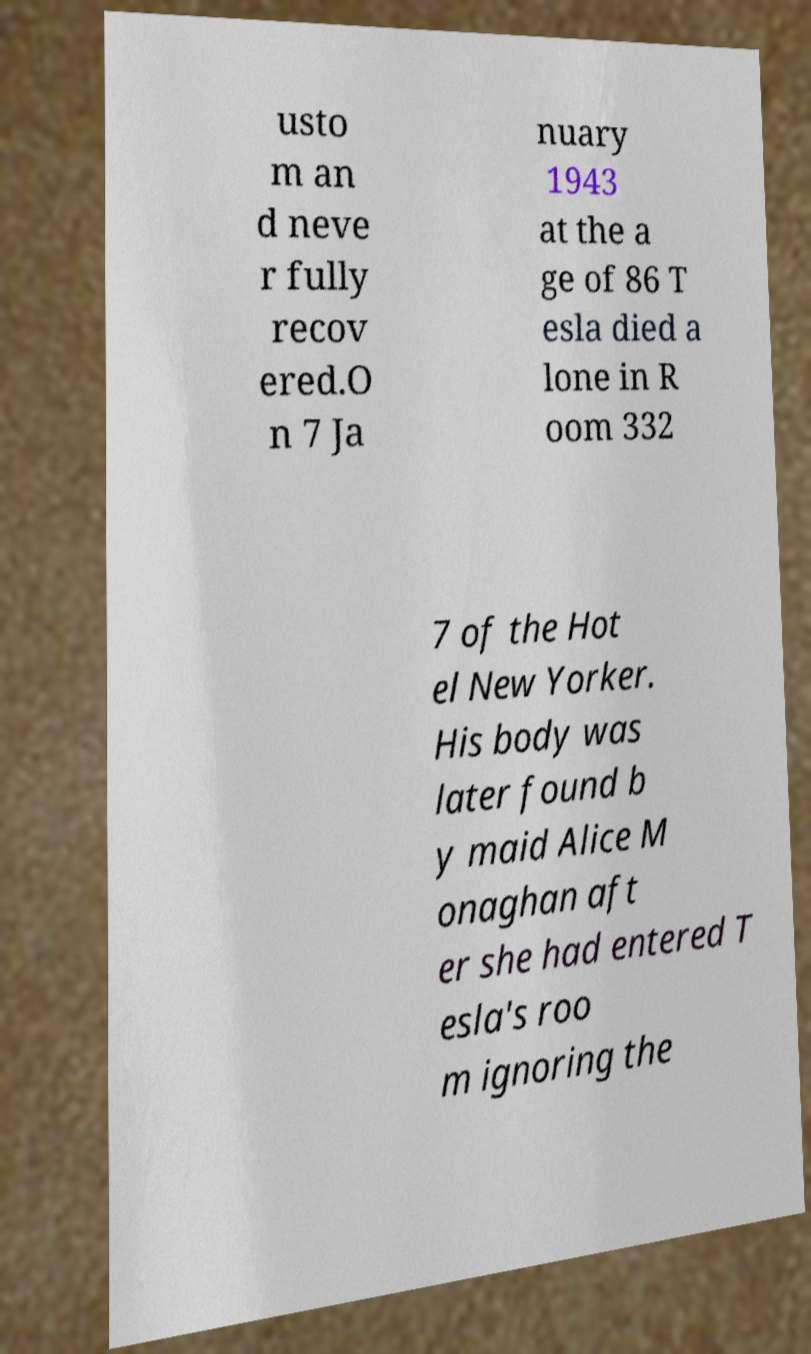I need the written content from this picture converted into text. Can you do that? usto m an d neve r fully recov ered.O n 7 Ja nuary 1943 at the a ge of 86 T esla died a lone in R oom 332 7 of the Hot el New Yorker. His body was later found b y maid Alice M onaghan aft er she had entered T esla's roo m ignoring the 